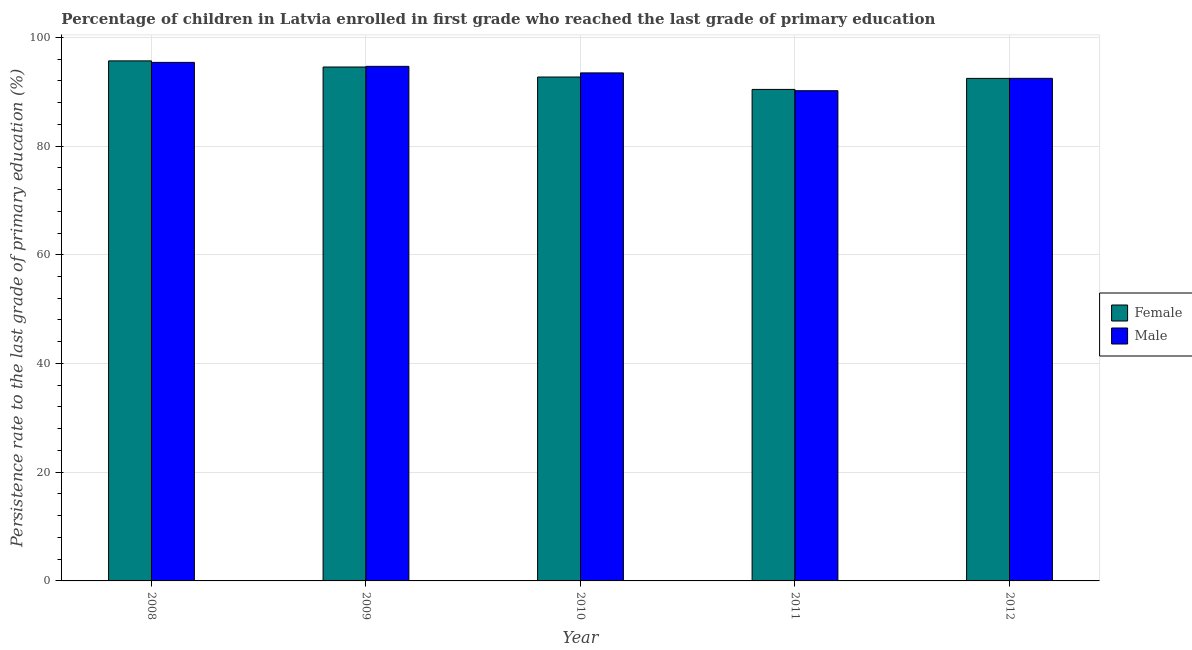Are the number of bars on each tick of the X-axis equal?
Ensure brevity in your answer.  Yes. How many bars are there on the 1st tick from the left?
Keep it short and to the point. 2. How many bars are there on the 2nd tick from the right?
Give a very brief answer. 2. In how many cases, is the number of bars for a given year not equal to the number of legend labels?
Your answer should be compact. 0. What is the persistence rate of male students in 2011?
Offer a terse response. 90.18. Across all years, what is the maximum persistence rate of female students?
Keep it short and to the point. 95.66. Across all years, what is the minimum persistence rate of male students?
Your answer should be compact. 90.18. In which year was the persistence rate of male students maximum?
Your response must be concise. 2008. What is the total persistence rate of male students in the graph?
Make the answer very short. 466.13. What is the difference between the persistence rate of male students in 2008 and that in 2009?
Your answer should be compact. 0.73. What is the difference between the persistence rate of male students in 2009 and the persistence rate of female students in 2010?
Your response must be concise. 1.2. What is the average persistence rate of male students per year?
Your answer should be very brief. 93.23. In the year 2012, what is the difference between the persistence rate of male students and persistence rate of female students?
Keep it short and to the point. 0. In how many years, is the persistence rate of female students greater than 76 %?
Give a very brief answer. 5. What is the ratio of the persistence rate of female students in 2008 to that in 2012?
Your response must be concise. 1.03. Is the persistence rate of male students in 2010 less than that in 2011?
Provide a short and direct response. No. What is the difference between the highest and the second highest persistence rate of male students?
Your answer should be very brief. 0.73. What is the difference between the highest and the lowest persistence rate of female students?
Your answer should be very brief. 5.25. How many bars are there?
Your response must be concise. 10. Are the values on the major ticks of Y-axis written in scientific E-notation?
Give a very brief answer. No. Does the graph contain any zero values?
Your answer should be compact. No. Does the graph contain grids?
Ensure brevity in your answer.  Yes. What is the title of the graph?
Provide a succinct answer. Percentage of children in Latvia enrolled in first grade who reached the last grade of primary education. What is the label or title of the X-axis?
Your answer should be compact. Year. What is the label or title of the Y-axis?
Offer a terse response. Persistence rate to the last grade of primary education (%). What is the Persistence rate to the last grade of primary education (%) in Female in 2008?
Make the answer very short. 95.66. What is the Persistence rate to the last grade of primary education (%) in Male in 2008?
Keep it short and to the point. 95.39. What is the Persistence rate to the last grade of primary education (%) in Female in 2009?
Give a very brief answer. 94.54. What is the Persistence rate to the last grade of primary education (%) of Male in 2009?
Provide a short and direct response. 94.66. What is the Persistence rate to the last grade of primary education (%) of Female in 2010?
Your answer should be compact. 92.7. What is the Persistence rate to the last grade of primary education (%) in Male in 2010?
Offer a terse response. 93.45. What is the Persistence rate to the last grade of primary education (%) in Female in 2011?
Keep it short and to the point. 90.41. What is the Persistence rate to the last grade of primary education (%) of Male in 2011?
Make the answer very short. 90.18. What is the Persistence rate to the last grade of primary education (%) in Female in 2012?
Offer a terse response. 92.44. What is the Persistence rate to the last grade of primary education (%) in Male in 2012?
Offer a terse response. 92.45. Across all years, what is the maximum Persistence rate to the last grade of primary education (%) in Female?
Ensure brevity in your answer.  95.66. Across all years, what is the maximum Persistence rate to the last grade of primary education (%) of Male?
Your answer should be compact. 95.39. Across all years, what is the minimum Persistence rate to the last grade of primary education (%) of Female?
Your answer should be very brief. 90.41. Across all years, what is the minimum Persistence rate to the last grade of primary education (%) of Male?
Give a very brief answer. 90.18. What is the total Persistence rate to the last grade of primary education (%) of Female in the graph?
Offer a very short reply. 465.76. What is the total Persistence rate to the last grade of primary education (%) of Male in the graph?
Your response must be concise. 466.13. What is the difference between the Persistence rate to the last grade of primary education (%) in Female in 2008 and that in 2009?
Offer a terse response. 1.13. What is the difference between the Persistence rate to the last grade of primary education (%) of Male in 2008 and that in 2009?
Your response must be concise. 0.73. What is the difference between the Persistence rate to the last grade of primary education (%) of Female in 2008 and that in 2010?
Keep it short and to the point. 2.97. What is the difference between the Persistence rate to the last grade of primary education (%) of Male in 2008 and that in 2010?
Keep it short and to the point. 1.94. What is the difference between the Persistence rate to the last grade of primary education (%) in Female in 2008 and that in 2011?
Provide a succinct answer. 5.25. What is the difference between the Persistence rate to the last grade of primary education (%) in Male in 2008 and that in 2011?
Provide a succinct answer. 5.21. What is the difference between the Persistence rate to the last grade of primary education (%) of Female in 2008 and that in 2012?
Your answer should be very brief. 3.22. What is the difference between the Persistence rate to the last grade of primary education (%) of Male in 2008 and that in 2012?
Provide a succinct answer. 2.94. What is the difference between the Persistence rate to the last grade of primary education (%) of Female in 2009 and that in 2010?
Provide a short and direct response. 1.84. What is the difference between the Persistence rate to the last grade of primary education (%) in Male in 2009 and that in 2010?
Make the answer very short. 1.2. What is the difference between the Persistence rate to the last grade of primary education (%) of Female in 2009 and that in 2011?
Your answer should be compact. 4.12. What is the difference between the Persistence rate to the last grade of primary education (%) in Male in 2009 and that in 2011?
Offer a terse response. 4.48. What is the difference between the Persistence rate to the last grade of primary education (%) in Female in 2009 and that in 2012?
Provide a succinct answer. 2.09. What is the difference between the Persistence rate to the last grade of primary education (%) in Male in 2009 and that in 2012?
Your answer should be compact. 2.2. What is the difference between the Persistence rate to the last grade of primary education (%) in Female in 2010 and that in 2011?
Give a very brief answer. 2.28. What is the difference between the Persistence rate to the last grade of primary education (%) in Male in 2010 and that in 2011?
Your response must be concise. 3.28. What is the difference between the Persistence rate to the last grade of primary education (%) in Female in 2010 and that in 2012?
Make the answer very short. 0.25. What is the difference between the Persistence rate to the last grade of primary education (%) of Female in 2011 and that in 2012?
Keep it short and to the point. -2.03. What is the difference between the Persistence rate to the last grade of primary education (%) in Male in 2011 and that in 2012?
Ensure brevity in your answer.  -2.28. What is the difference between the Persistence rate to the last grade of primary education (%) in Female in 2008 and the Persistence rate to the last grade of primary education (%) in Male in 2009?
Your response must be concise. 1.01. What is the difference between the Persistence rate to the last grade of primary education (%) in Female in 2008 and the Persistence rate to the last grade of primary education (%) in Male in 2010?
Your response must be concise. 2.21. What is the difference between the Persistence rate to the last grade of primary education (%) in Female in 2008 and the Persistence rate to the last grade of primary education (%) in Male in 2011?
Provide a short and direct response. 5.49. What is the difference between the Persistence rate to the last grade of primary education (%) in Female in 2008 and the Persistence rate to the last grade of primary education (%) in Male in 2012?
Give a very brief answer. 3.21. What is the difference between the Persistence rate to the last grade of primary education (%) of Female in 2009 and the Persistence rate to the last grade of primary education (%) of Male in 2010?
Make the answer very short. 1.08. What is the difference between the Persistence rate to the last grade of primary education (%) of Female in 2009 and the Persistence rate to the last grade of primary education (%) of Male in 2011?
Offer a terse response. 4.36. What is the difference between the Persistence rate to the last grade of primary education (%) in Female in 2009 and the Persistence rate to the last grade of primary education (%) in Male in 2012?
Offer a very short reply. 2.08. What is the difference between the Persistence rate to the last grade of primary education (%) in Female in 2010 and the Persistence rate to the last grade of primary education (%) in Male in 2011?
Make the answer very short. 2.52. What is the difference between the Persistence rate to the last grade of primary education (%) in Female in 2010 and the Persistence rate to the last grade of primary education (%) in Male in 2012?
Provide a succinct answer. 0.24. What is the difference between the Persistence rate to the last grade of primary education (%) of Female in 2011 and the Persistence rate to the last grade of primary education (%) of Male in 2012?
Keep it short and to the point. -2.04. What is the average Persistence rate to the last grade of primary education (%) in Female per year?
Offer a very short reply. 93.15. What is the average Persistence rate to the last grade of primary education (%) of Male per year?
Keep it short and to the point. 93.23. In the year 2008, what is the difference between the Persistence rate to the last grade of primary education (%) in Female and Persistence rate to the last grade of primary education (%) in Male?
Your answer should be compact. 0.28. In the year 2009, what is the difference between the Persistence rate to the last grade of primary education (%) in Female and Persistence rate to the last grade of primary education (%) in Male?
Offer a terse response. -0.12. In the year 2010, what is the difference between the Persistence rate to the last grade of primary education (%) of Female and Persistence rate to the last grade of primary education (%) of Male?
Offer a terse response. -0.76. In the year 2011, what is the difference between the Persistence rate to the last grade of primary education (%) of Female and Persistence rate to the last grade of primary education (%) of Male?
Your answer should be very brief. 0.24. In the year 2012, what is the difference between the Persistence rate to the last grade of primary education (%) in Female and Persistence rate to the last grade of primary education (%) in Male?
Give a very brief answer. -0.01. What is the ratio of the Persistence rate to the last grade of primary education (%) in Female in 2008 to that in 2009?
Provide a succinct answer. 1.01. What is the ratio of the Persistence rate to the last grade of primary education (%) in Male in 2008 to that in 2009?
Offer a very short reply. 1.01. What is the ratio of the Persistence rate to the last grade of primary education (%) in Female in 2008 to that in 2010?
Provide a short and direct response. 1.03. What is the ratio of the Persistence rate to the last grade of primary education (%) in Male in 2008 to that in 2010?
Provide a short and direct response. 1.02. What is the ratio of the Persistence rate to the last grade of primary education (%) of Female in 2008 to that in 2011?
Ensure brevity in your answer.  1.06. What is the ratio of the Persistence rate to the last grade of primary education (%) of Male in 2008 to that in 2011?
Give a very brief answer. 1.06. What is the ratio of the Persistence rate to the last grade of primary education (%) of Female in 2008 to that in 2012?
Ensure brevity in your answer.  1.03. What is the ratio of the Persistence rate to the last grade of primary education (%) of Male in 2008 to that in 2012?
Your answer should be compact. 1.03. What is the ratio of the Persistence rate to the last grade of primary education (%) in Female in 2009 to that in 2010?
Ensure brevity in your answer.  1.02. What is the ratio of the Persistence rate to the last grade of primary education (%) of Male in 2009 to that in 2010?
Make the answer very short. 1.01. What is the ratio of the Persistence rate to the last grade of primary education (%) of Female in 2009 to that in 2011?
Offer a very short reply. 1.05. What is the ratio of the Persistence rate to the last grade of primary education (%) of Male in 2009 to that in 2011?
Your answer should be compact. 1.05. What is the ratio of the Persistence rate to the last grade of primary education (%) of Female in 2009 to that in 2012?
Your response must be concise. 1.02. What is the ratio of the Persistence rate to the last grade of primary education (%) of Male in 2009 to that in 2012?
Your response must be concise. 1.02. What is the ratio of the Persistence rate to the last grade of primary education (%) in Female in 2010 to that in 2011?
Offer a very short reply. 1.03. What is the ratio of the Persistence rate to the last grade of primary education (%) in Male in 2010 to that in 2011?
Provide a succinct answer. 1.04. What is the ratio of the Persistence rate to the last grade of primary education (%) of Male in 2010 to that in 2012?
Offer a very short reply. 1.01. What is the ratio of the Persistence rate to the last grade of primary education (%) in Female in 2011 to that in 2012?
Make the answer very short. 0.98. What is the ratio of the Persistence rate to the last grade of primary education (%) of Male in 2011 to that in 2012?
Offer a terse response. 0.98. What is the difference between the highest and the second highest Persistence rate to the last grade of primary education (%) of Female?
Keep it short and to the point. 1.13. What is the difference between the highest and the second highest Persistence rate to the last grade of primary education (%) of Male?
Provide a short and direct response. 0.73. What is the difference between the highest and the lowest Persistence rate to the last grade of primary education (%) of Female?
Give a very brief answer. 5.25. What is the difference between the highest and the lowest Persistence rate to the last grade of primary education (%) of Male?
Give a very brief answer. 5.21. 